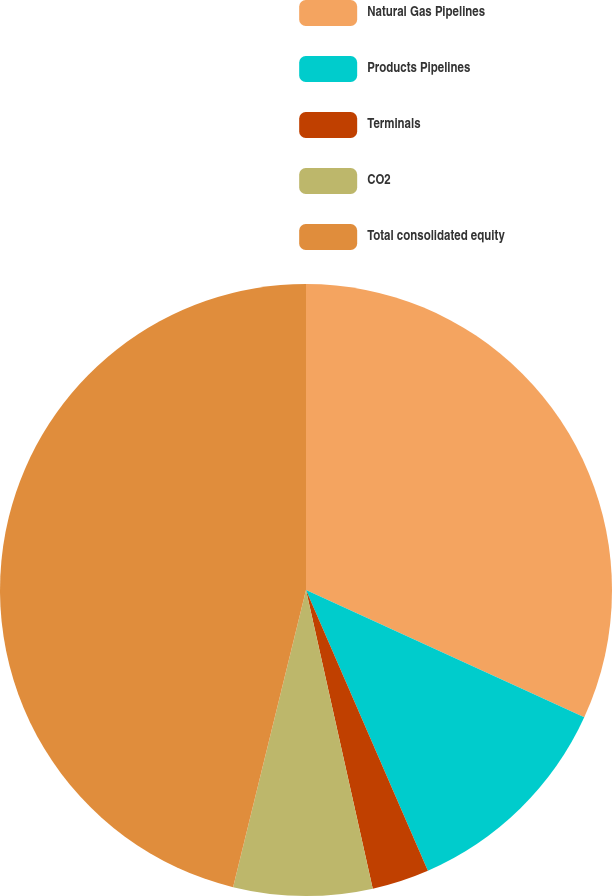Convert chart to OTSL. <chart><loc_0><loc_0><loc_500><loc_500><pie_chart><fcel>Natural Gas Pipelines<fcel>Products Pipelines<fcel>Terminals<fcel>CO2<fcel>Total consolidated equity<nl><fcel>31.83%<fcel>11.65%<fcel>3.02%<fcel>7.33%<fcel>46.17%<nl></chart> 